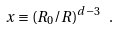Convert formula to latex. <formula><loc_0><loc_0><loc_500><loc_500>x \equiv ( R _ { 0 } / R ) ^ { d - 3 } \ .</formula> 